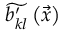Convert formula to latex. <formula><loc_0><loc_0><loc_500><loc_500>\widetilde { b _ { k l } ^ { \prime } } \left ( \vec { x } \right )</formula> 